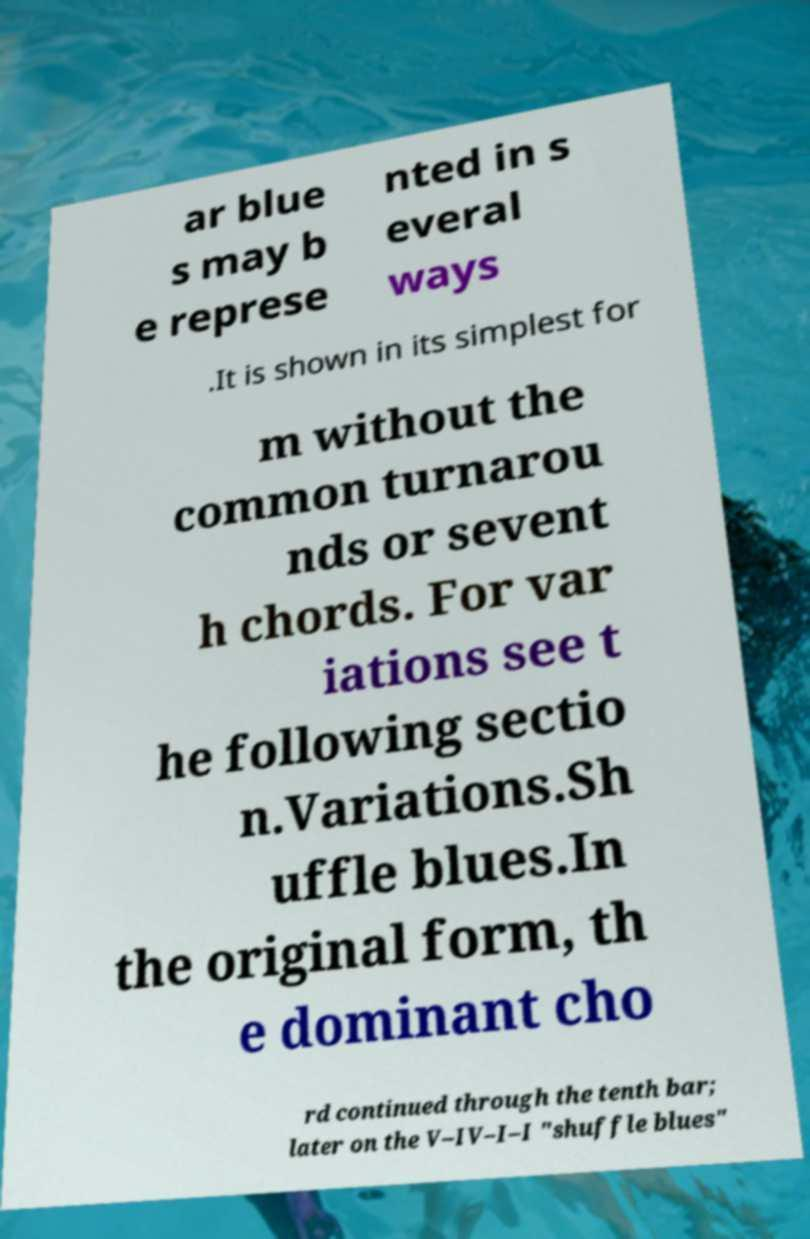For documentation purposes, I need the text within this image transcribed. Could you provide that? ar blue s may b e represe nted in s everal ways .It is shown in its simplest for m without the common turnarou nds or sevent h chords. For var iations see t he following sectio n.Variations.Sh uffle blues.In the original form, th e dominant cho rd continued through the tenth bar; later on the V–IV–I–I "shuffle blues" 